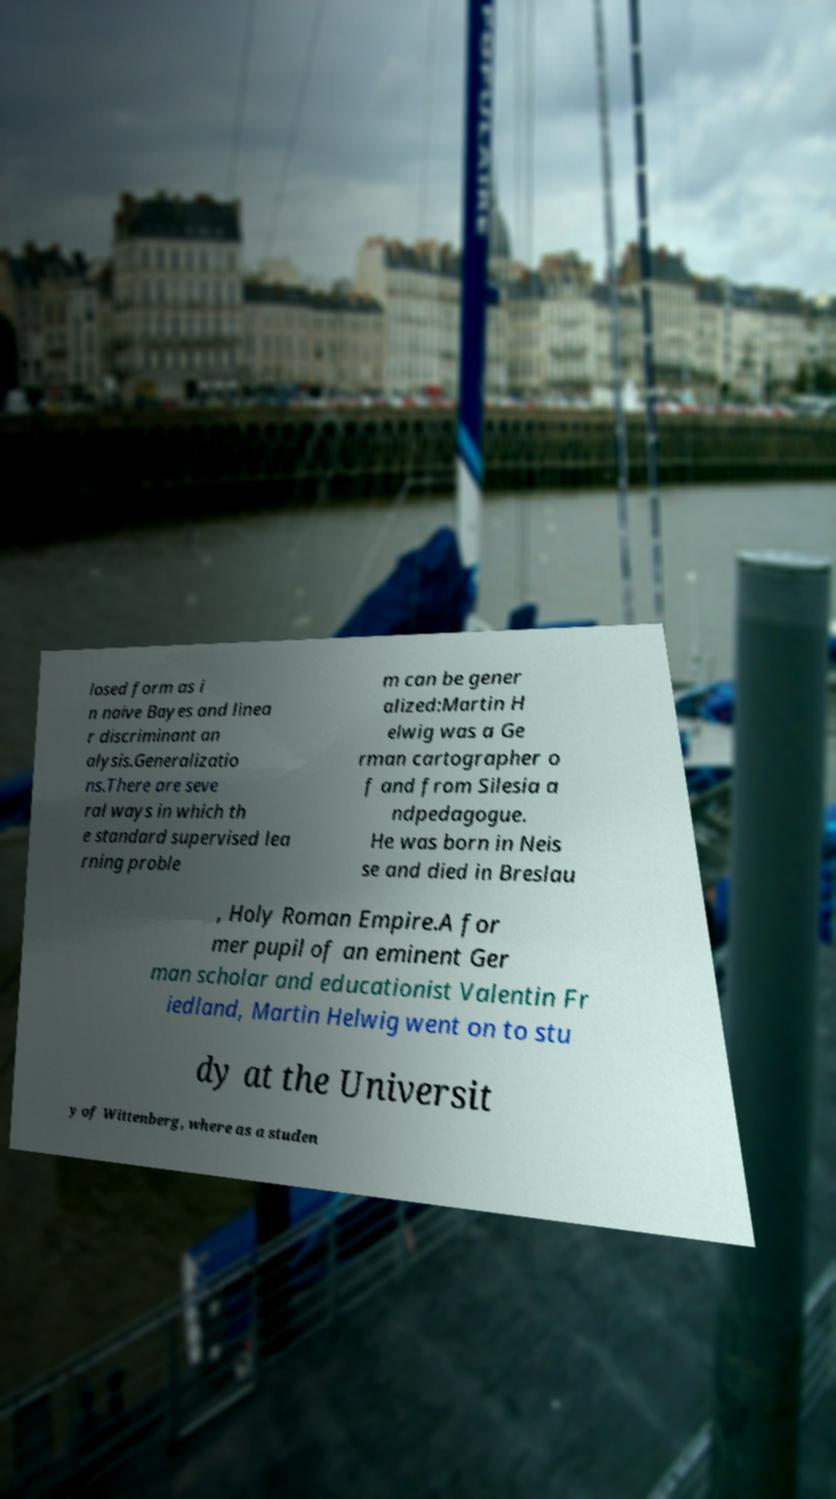Can you read and provide the text displayed in the image?This photo seems to have some interesting text. Can you extract and type it out for me? losed form as i n naive Bayes and linea r discriminant an alysis.Generalizatio ns.There are seve ral ways in which th e standard supervised lea rning proble m can be gener alized:Martin H elwig was a Ge rman cartographer o f and from Silesia a ndpedagogue. He was born in Neis se and died in Breslau , Holy Roman Empire.A for mer pupil of an eminent Ger man scholar and educationist Valentin Fr iedland, Martin Helwig went on to stu dy at the Universit y of Wittenberg, where as a studen 